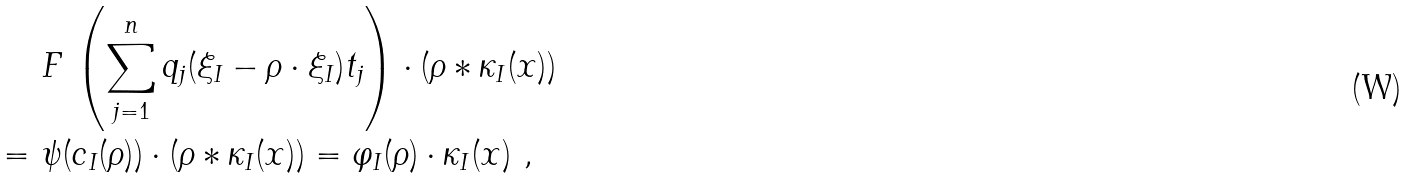Convert formula to latex. <formula><loc_0><loc_0><loc_500><loc_500>& F \, \left ( \sum _ { j = 1 } ^ { n } q _ { j } ( \xi _ { I } - \rho \cdot \xi _ { I } ) t _ { j } \right ) \cdot ( \rho \ast \kappa _ { I } ( x ) ) \\ = \ & \psi ( c _ { I } ( \rho ) ) \cdot ( \rho \ast \kappa _ { I } ( x ) ) = \varphi _ { I } ( \rho ) \cdot \kappa _ { I } ( x ) \ ,</formula> 